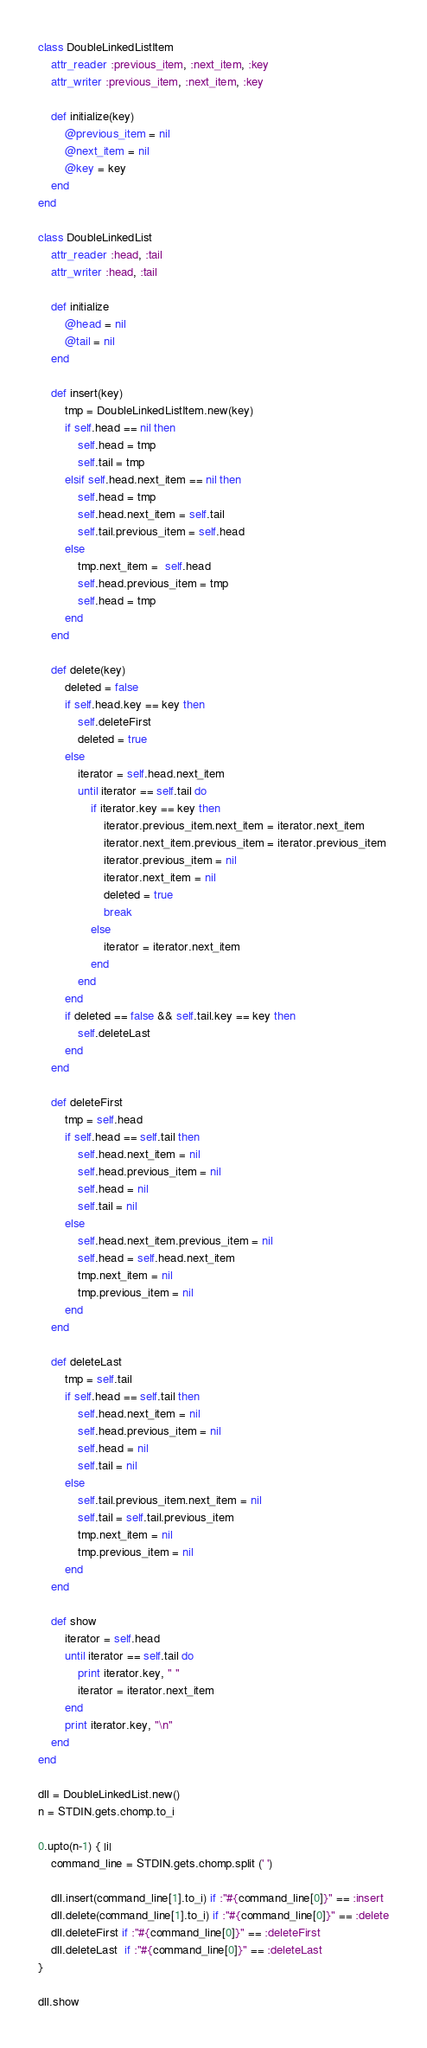<code> <loc_0><loc_0><loc_500><loc_500><_Ruby_>class DoubleLinkedListItem
	attr_reader :previous_item, :next_item, :key
	attr_writer :previous_item, :next_item, :key
	
	def initialize(key)
		@previous_item = nil
		@next_item = nil
		@key = key
	end
end

class DoubleLinkedList
	attr_reader :head, :tail
	attr_writer :head, :tail

	def initialize
		@head = nil
		@tail = nil
	end
	
	def insert(key)
		tmp = DoubleLinkedListItem.new(key)
		if self.head == nil then
			self.head = tmp
			self.tail = tmp
		elsif self.head.next_item == nil then
			self.head = tmp
			self.head.next_item = self.tail
			self.tail.previous_item = self.head
		else
			tmp.next_item =  self.head
			self.head.previous_item = tmp
			self.head = tmp
		end
	end
	
	def delete(key)
		deleted = false
		if self.head.key == key then
			self.deleteFirst
			deleted = true
		else
			iterator = self.head.next_item
			until iterator == self.tail do
				if iterator.key == key then
					iterator.previous_item.next_item = iterator.next_item
					iterator.next_item.previous_item = iterator.previous_item
					iterator.previous_item = nil
					iterator.next_item = nil
					deleted = true
					break
				else
					iterator = iterator.next_item
				end
			end
		end
		if deleted == false && self.tail.key == key then
			self.deleteLast
		end
	end
	
	def deleteFirst
		tmp = self.head
		if self.head == self.tail then
			self.head.next_item = nil
			self.head.previous_item = nil
			self.head = nil
			self.tail = nil
		else
			self.head.next_item.previous_item = nil
			self.head = self.head.next_item
			tmp.next_item = nil
			tmp.previous_item = nil
		end
	end
	
	def deleteLast
		tmp = self.tail
		if self.head == self.tail then
			self.head.next_item = nil
			self.head.previous_item = nil
			self.head = nil
			self.tail = nil
		else
			self.tail.previous_item.next_item = nil
			self.tail = self.tail.previous_item
			tmp.next_item = nil
			tmp.previous_item = nil
		end
	end
	
	def show
		iterator = self.head
		until iterator == self.tail do
			print iterator.key, " "
			iterator = iterator.next_item
		end
		print iterator.key, "\n"
	end
end

dll = DoubleLinkedList.new()
n = STDIN.gets.chomp.to_i

0.upto(n-1) { |i|
	command_line = STDIN.gets.chomp.split (' ')
	
	dll.insert(command_line[1].to_i) if :"#{command_line[0]}" == :insert
	dll.delete(command_line[1].to_i) if :"#{command_line[0]}" == :delete
	dll.deleteFirst if :"#{command_line[0]}" == :deleteFirst
	dll.deleteLast  if :"#{command_line[0]}" == :deleteLast
}

dll.show
</code> 